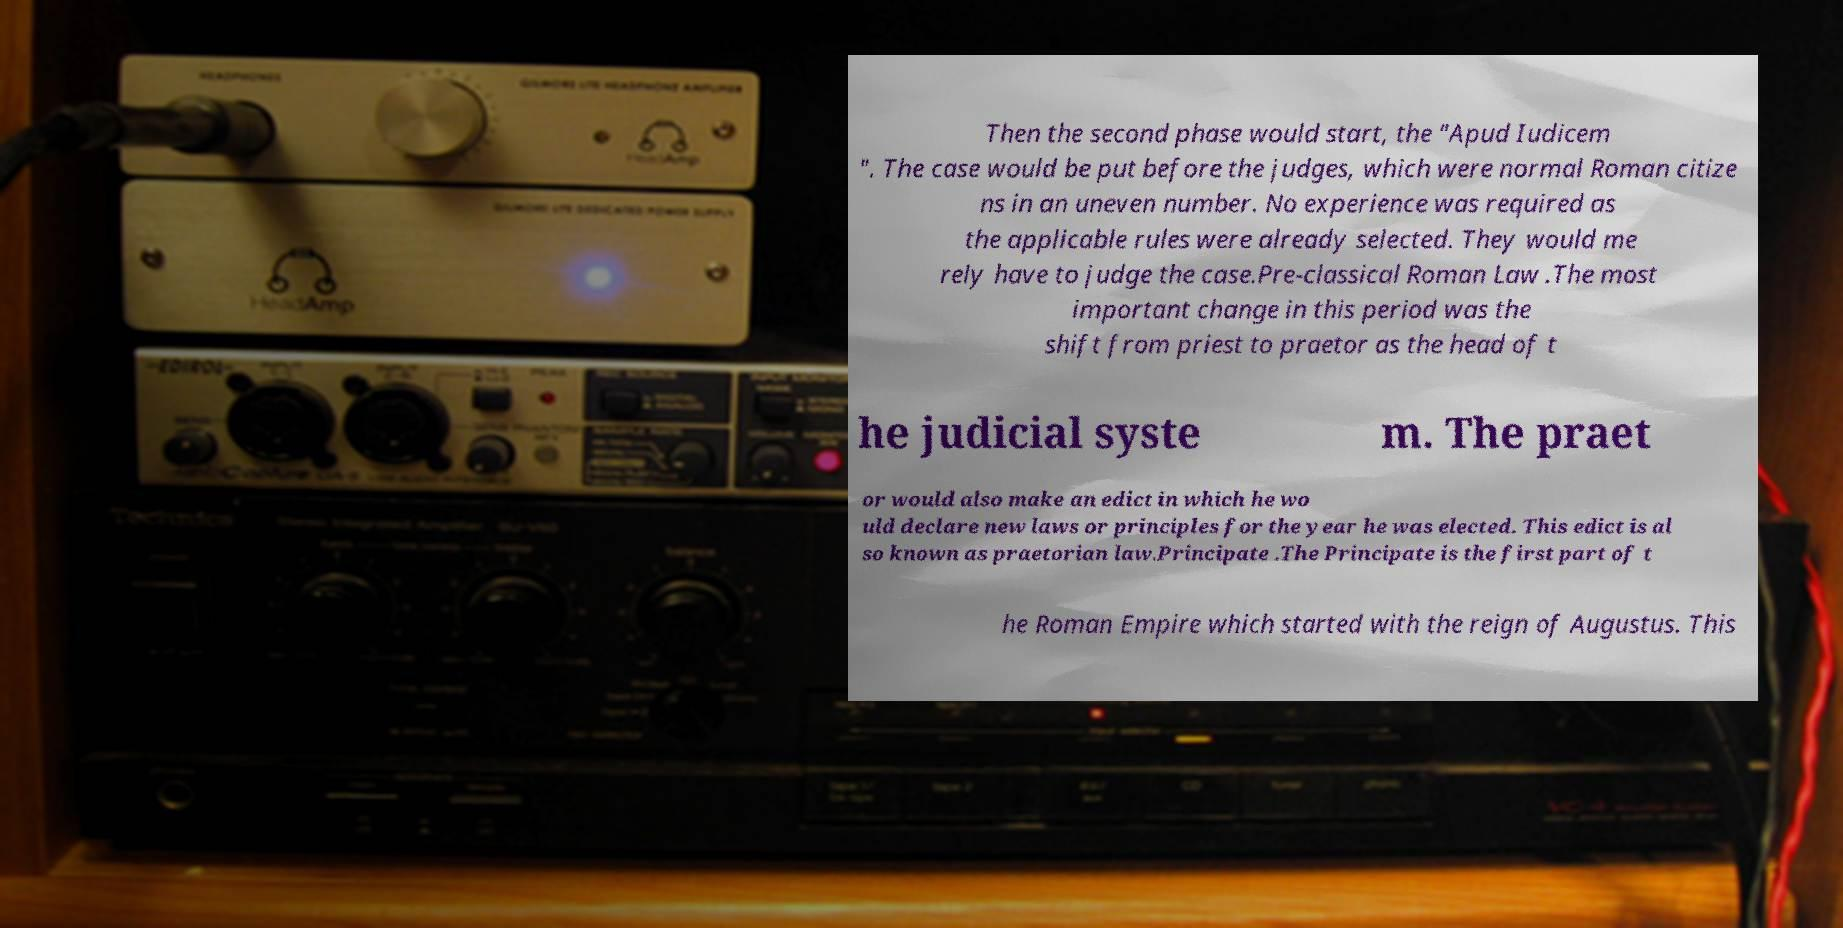Please read and relay the text visible in this image. What does it say? Then the second phase would start, the "Apud Iudicem ". The case would be put before the judges, which were normal Roman citize ns in an uneven number. No experience was required as the applicable rules were already selected. They would me rely have to judge the case.Pre-classical Roman Law .The most important change in this period was the shift from priest to praetor as the head of t he judicial syste m. The praet or would also make an edict in which he wo uld declare new laws or principles for the year he was elected. This edict is al so known as praetorian law.Principate .The Principate is the first part of t he Roman Empire which started with the reign of Augustus. This 